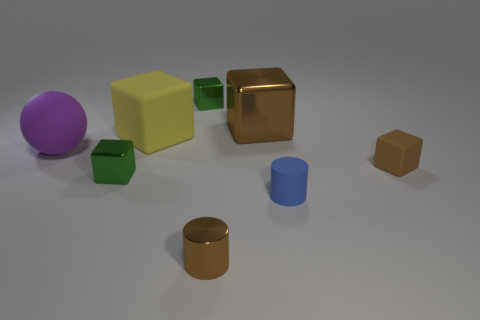What size is the brown rubber cube?
Give a very brief answer. Small. Do the brown thing behind the big purple matte object and the blue object that is in front of the large yellow cube have the same size?
Your answer should be compact. No. What size is the yellow matte object that is the same shape as the big brown shiny thing?
Offer a very short reply. Large. Is the size of the blue rubber cylinder the same as the rubber cube on the right side of the tiny brown cylinder?
Your answer should be compact. Yes. Are there any tiny brown rubber blocks that are left of the green object in front of the purple thing?
Give a very brief answer. No. What is the shape of the tiny rubber object right of the small blue thing?
Make the answer very short. Cube. What material is the tiny cylinder that is the same color as the small rubber cube?
Give a very brief answer. Metal. What is the color of the cylinder that is to the right of the brown shiny thing that is behind the purple thing?
Make the answer very short. Blue. Is the size of the yellow block the same as the purple thing?
Provide a succinct answer. Yes. What material is the other large object that is the same shape as the yellow matte thing?
Provide a short and direct response. Metal. 